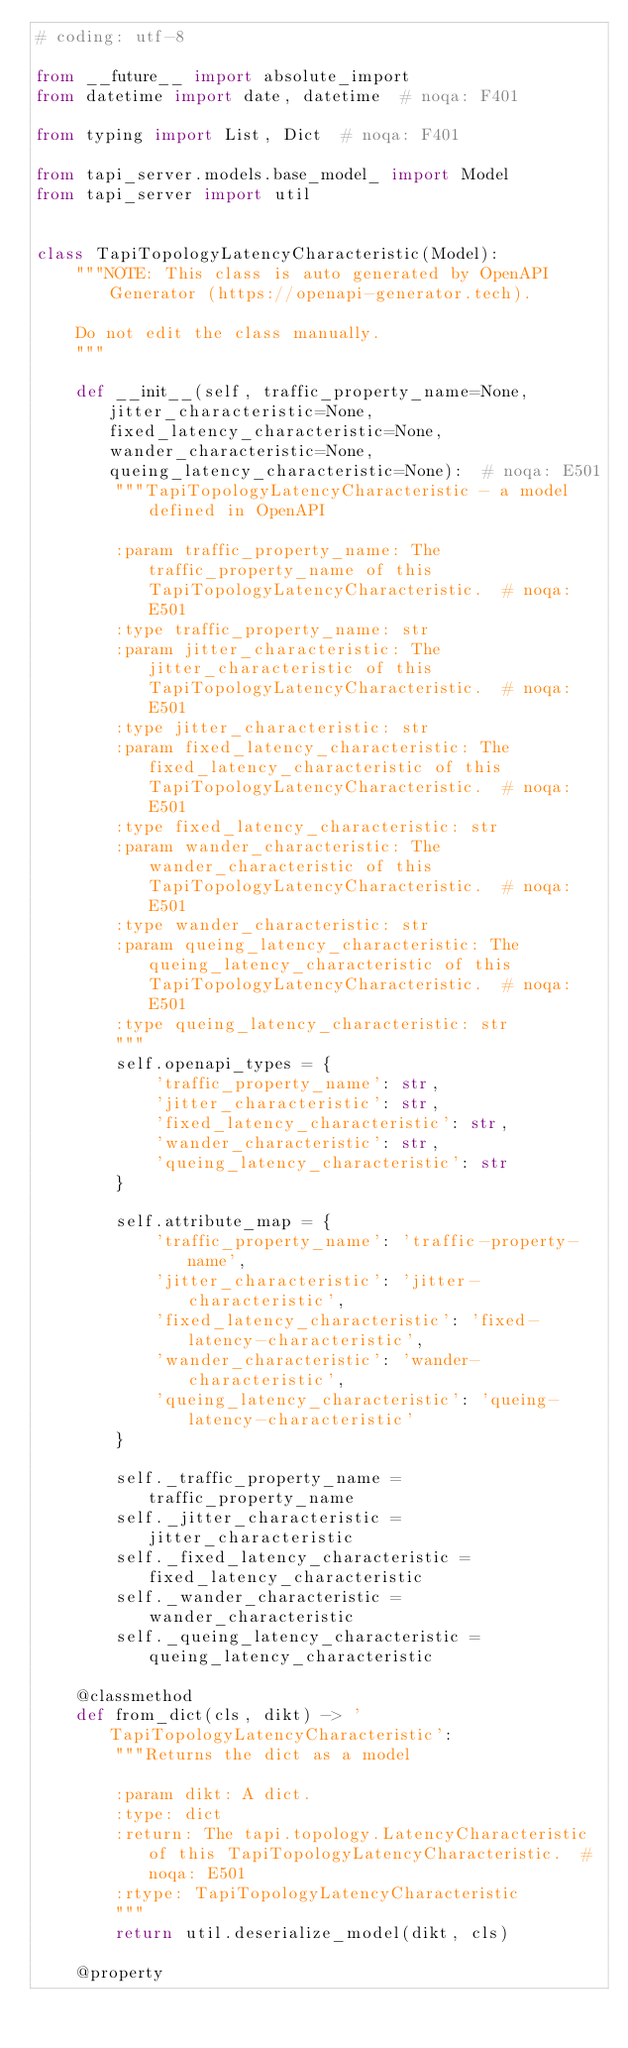Convert code to text. <code><loc_0><loc_0><loc_500><loc_500><_Python_># coding: utf-8

from __future__ import absolute_import
from datetime import date, datetime  # noqa: F401

from typing import List, Dict  # noqa: F401

from tapi_server.models.base_model_ import Model
from tapi_server import util


class TapiTopologyLatencyCharacteristic(Model):
    """NOTE: This class is auto generated by OpenAPI Generator (https://openapi-generator.tech).

    Do not edit the class manually.
    """

    def __init__(self, traffic_property_name=None, jitter_characteristic=None, fixed_latency_characteristic=None, wander_characteristic=None, queing_latency_characteristic=None):  # noqa: E501
        """TapiTopologyLatencyCharacteristic - a model defined in OpenAPI

        :param traffic_property_name: The traffic_property_name of this TapiTopologyLatencyCharacteristic.  # noqa: E501
        :type traffic_property_name: str
        :param jitter_characteristic: The jitter_characteristic of this TapiTopologyLatencyCharacteristic.  # noqa: E501
        :type jitter_characteristic: str
        :param fixed_latency_characteristic: The fixed_latency_characteristic of this TapiTopologyLatencyCharacteristic.  # noqa: E501
        :type fixed_latency_characteristic: str
        :param wander_characteristic: The wander_characteristic of this TapiTopologyLatencyCharacteristic.  # noqa: E501
        :type wander_characteristic: str
        :param queing_latency_characteristic: The queing_latency_characteristic of this TapiTopologyLatencyCharacteristic.  # noqa: E501
        :type queing_latency_characteristic: str
        """
        self.openapi_types = {
            'traffic_property_name': str,
            'jitter_characteristic': str,
            'fixed_latency_characteristic': str,
            'wander_characteristic': str,
            'queing_latency_characteristic': str
        }

        self.attribute_map = {
            'traffic_property_name': 'traffic-property-name',
            'jitter_characteristic': 'jitter-characteristic',
            'fixed_latency_characteristic': 'fixed-latency-characteristic',
            'wander_characteristic': 'wander-characteristic',
            'queing_latency_characteristic': 'queing-latency-characteristic'
        }

        self._traffic_property_name = traffic_property_name
        self._jitter_characteristic = jitter_characteristic
        self._fixed_latency_characteristic = fixed_latency_characteristic
        self._wander_characteristic = wander_characteristic
        self._queing_latency_characteristic = queing_latency_characteristic

    @classmethod
    def from_dict(cls, dikt) -> 'TapiTopologyLatencyCharacteristic':
        """Returns the dict as a model

        :param dikt: A dict.
        :type: dict
        :return: The tapi.topology.LatencyCharacteristic of this TapiTopologyLatencyCharacteristic.  # noqa: E501
        :rtype: TapiTopologyLatencyCharacteristic
        """
        return util.deserialize_model(dikt, cls)

    @property</code> 